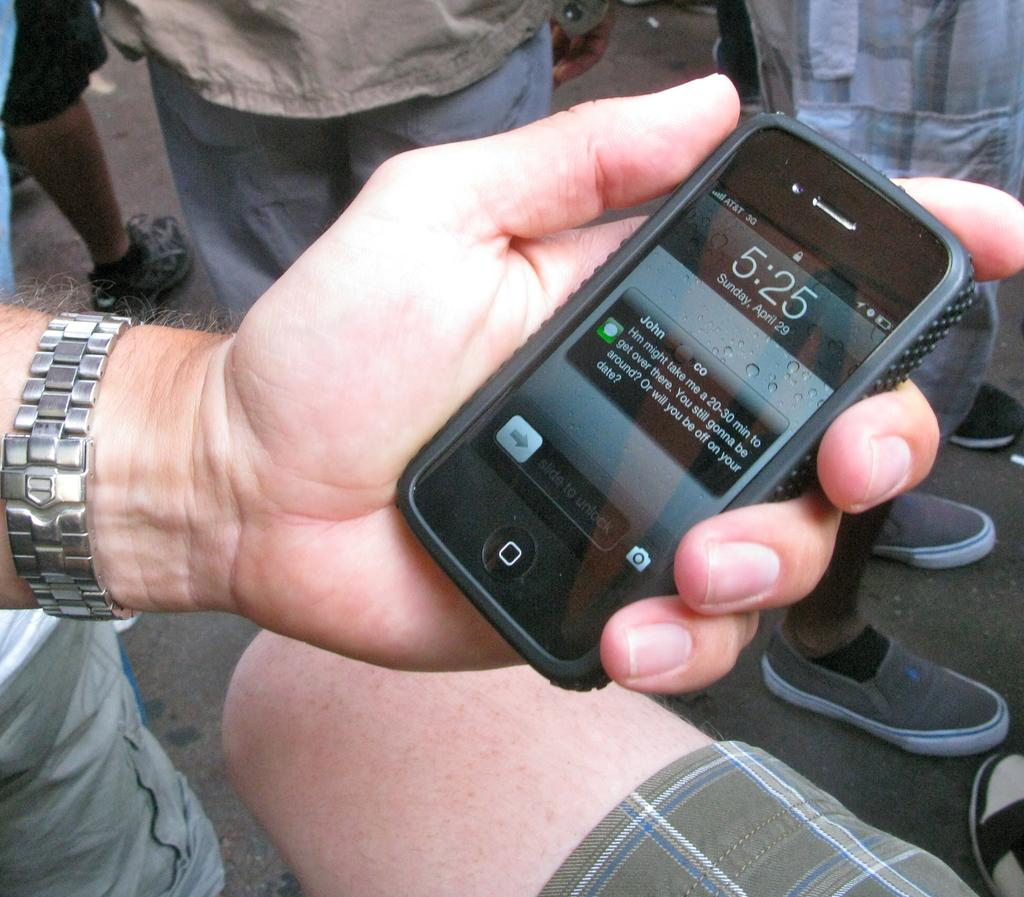What is the person holding in the image? There is a hand holding a cellphone in the image. What can be seen in the background of the image? There are people standing on the road in the image. What type of skin is visible on the cellphone in the image? There is no skin visible on the cellphone in the image; it is an electronic device. 